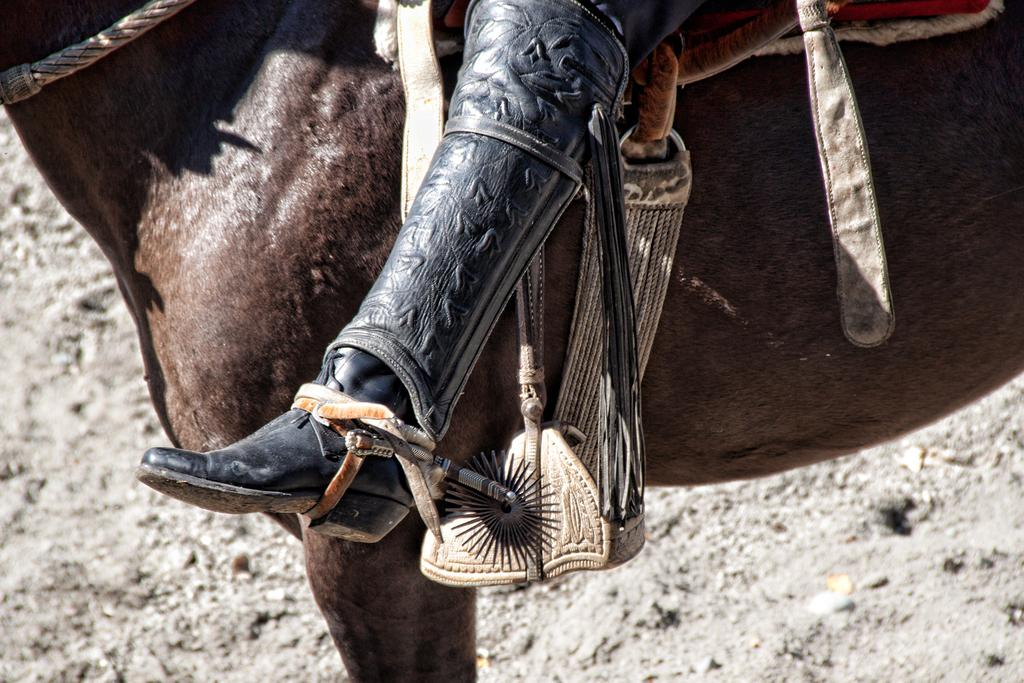What is the main subject in the center of the image? There is a horse in the center of the image. Is there anyone interacting with the horse in the image? Yes, there is a person sitting on the horse. What type of surface is visible at the bottom of the image? There is sand at the bottom of the image. What items are on the list that the horse is holding in the image? There is no list present in the image, and the horse is not holding any items. 